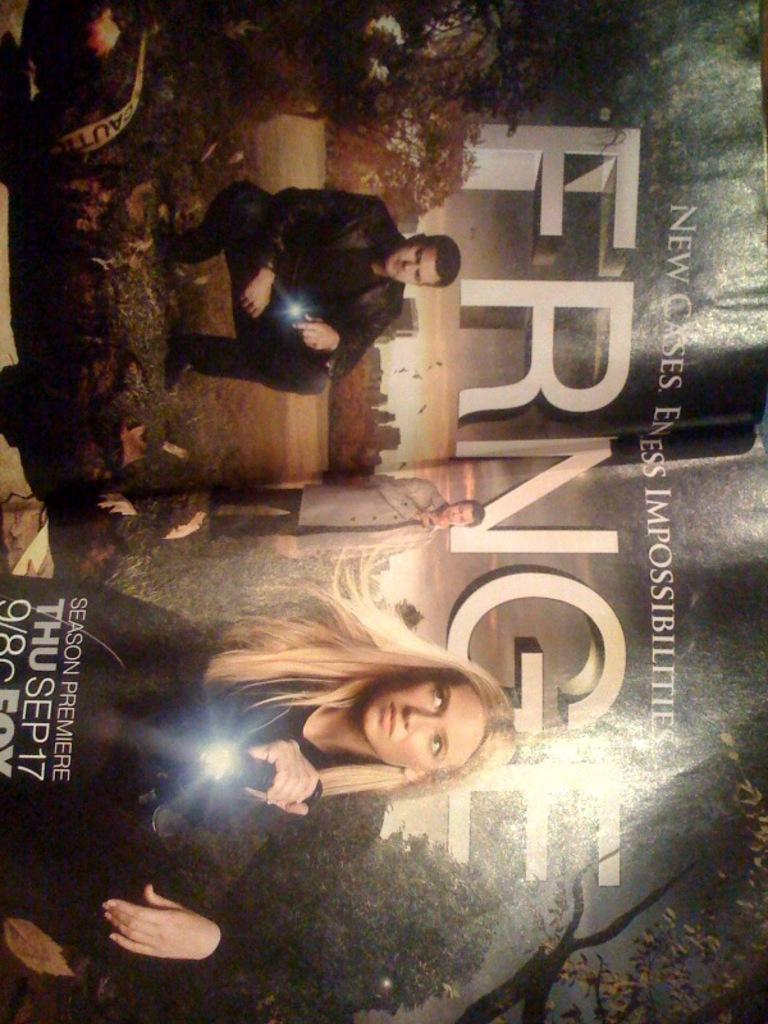<image>
Provide a brief description of the given image. Television show poster for The Fringe that premiees September 17th. 